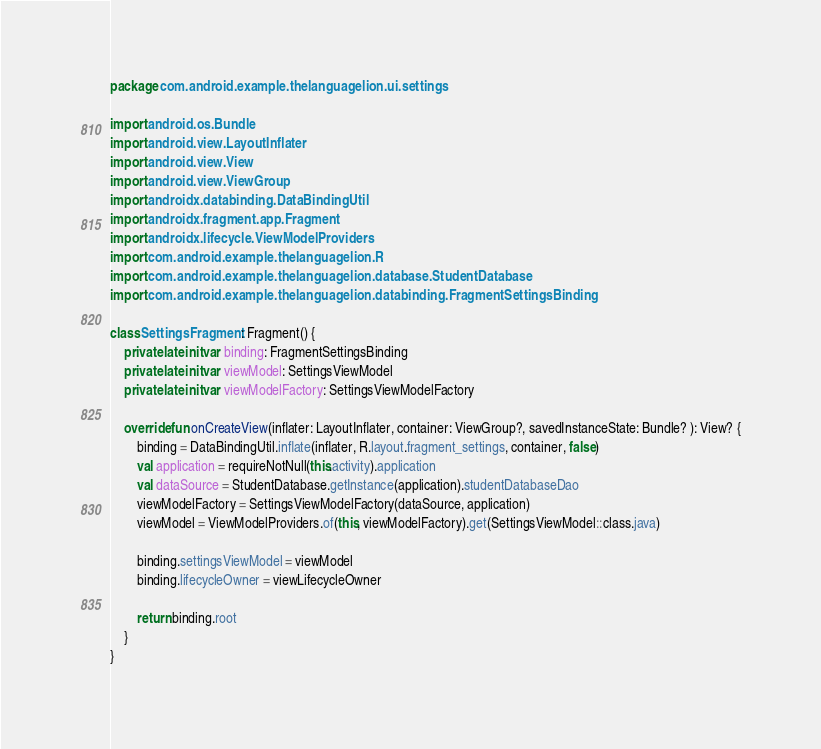Convert code to text. <code><loc_0><loc_0><loc_500><loc_500><_Kotlin_>package com.android.example.thelanguagelion.ui.settings

import android.os.Bundle
import android.view.LayoutInflater
import android.view.View
import android.view.ViewGroup
import androidx.databinding.DataBindingUtil
import androidx.fragment.app.Fragment
import androidx.lifecycle.ViewModelProviders
import com.android.example.thelanguagelion.R
import com.android.example.thelanguagelion.database.StudentDatabase
import com.android.example.thelanguagelion.databinding.FragmentSettingsBinding

class SettingsFragment : Fragment() {
    private lateinit var binding: FragmentSettingsBinding
    private lateinit var viewModel: SettingsViewModel
    private lateinit var viewModelFactory: SettingsViewModelFactory

    override fun onCreateView(inflater: LayoutInflater, container: ViewGroup?, savedInstanceState: Bundle? ): View? {
        binding = DataBindingUtil.inflate(inflater, R.layout.fragment_settings, container, false)
        val application = requireNotNull(this.activity).application
        val dataSource = StudentDatabase.getInstance(application).studentDatabaseDao
        viewModelFactory = SettingsViewModelFactory(dataSource, application)
        viewModel = ViewModelProviders.of(this, viewModelFactory).get(SettingsViewModel::class.java)

        binding.settingsViewModel = viewModel
        binding.lifecycleOwner = viewLifecycleOwner

        return binding.root
    }
}
</code> 